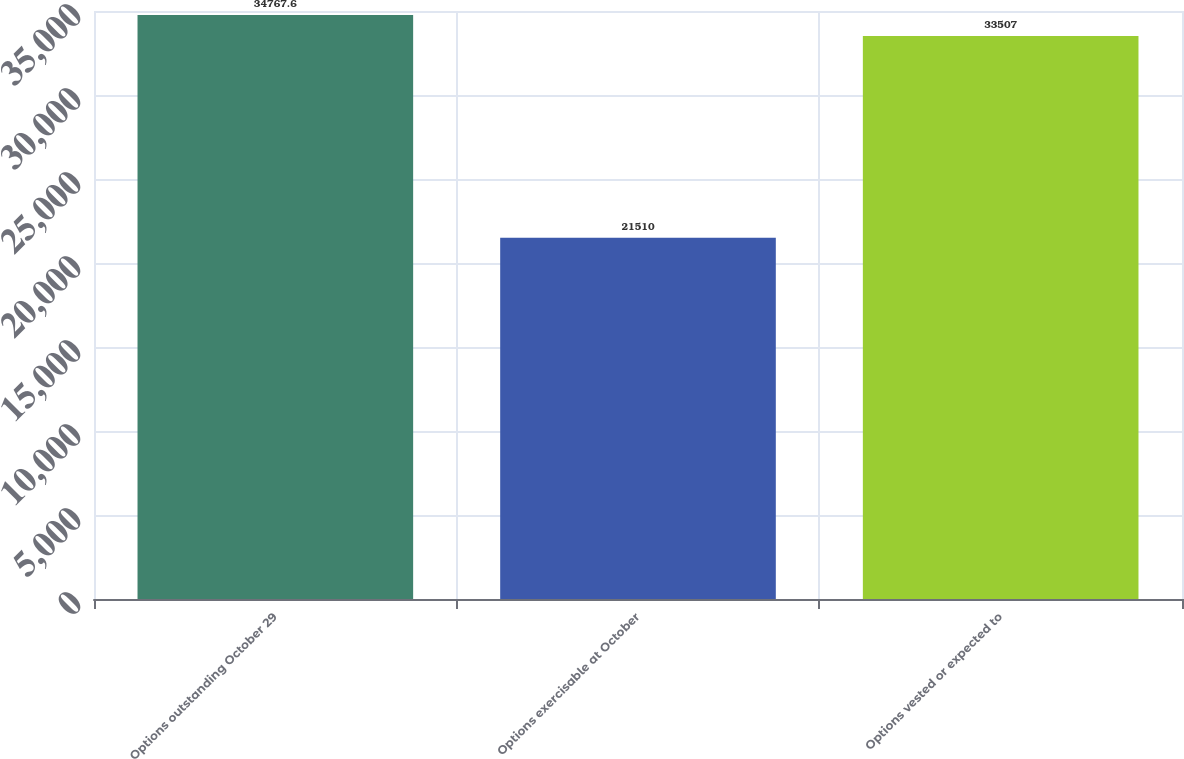Convert chart. <chart><loc_0><loc_0><loc_500><loc_500><bar_chart><fcel>Options outstanding October 29<fcel>Options exercisable at October<fcel>Options vested or expected to<nl><fcel>34767.6<fcel>21510<fcel>33507<nl></chart> 